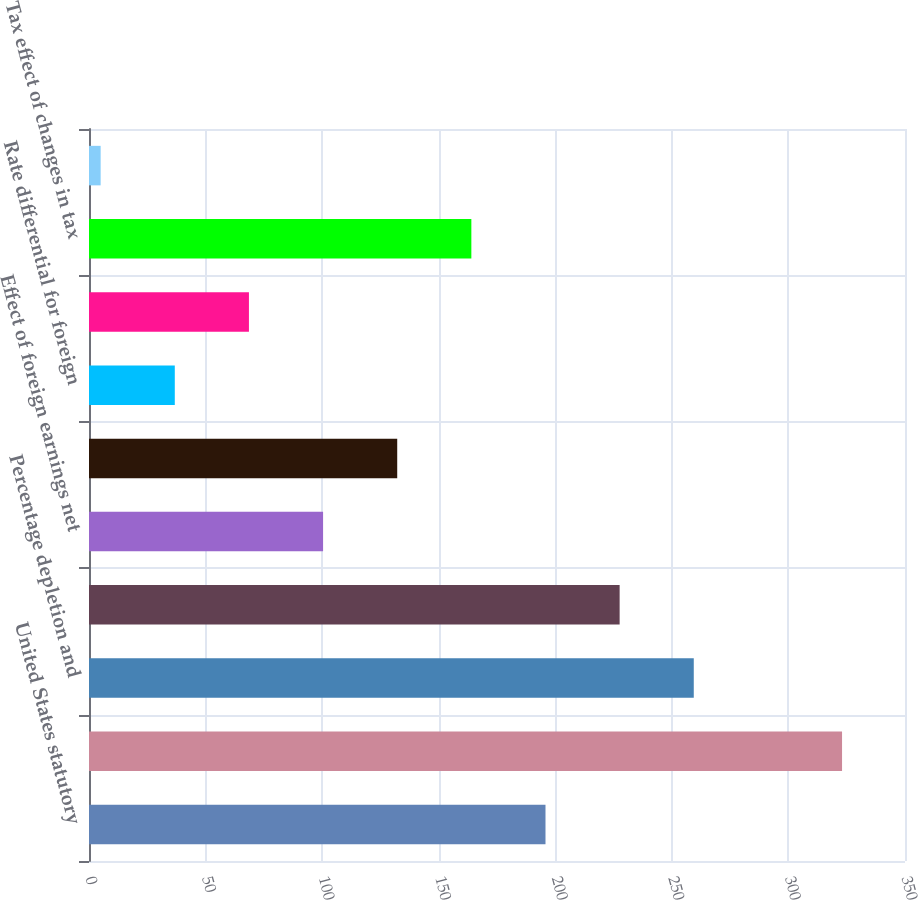Convert chart to OTSL. <chart><loc_0><loc_0><loc_500><loc_500><bar_chart><fcel>United States statutory<fcel>Income tax (expense) benefit<fcel>Percentage depletion and<fcel>Change in valuation allowance<fcel>Effect of foreign earnings net<fcel>US tax effect of minority<fcel>Rate differential for foreign<fcel>FIN 48 resolution of prior<fcel>Tax effect of changes in tax<fcel>Other<nl><fcel>195.8<fcel>323<fcel>259.4<fcel>227.6<fcel>100.4<fcel>132.2<fcel>36.8<fcel>68.6<fcel>164<fcel>5<nl></chart> 